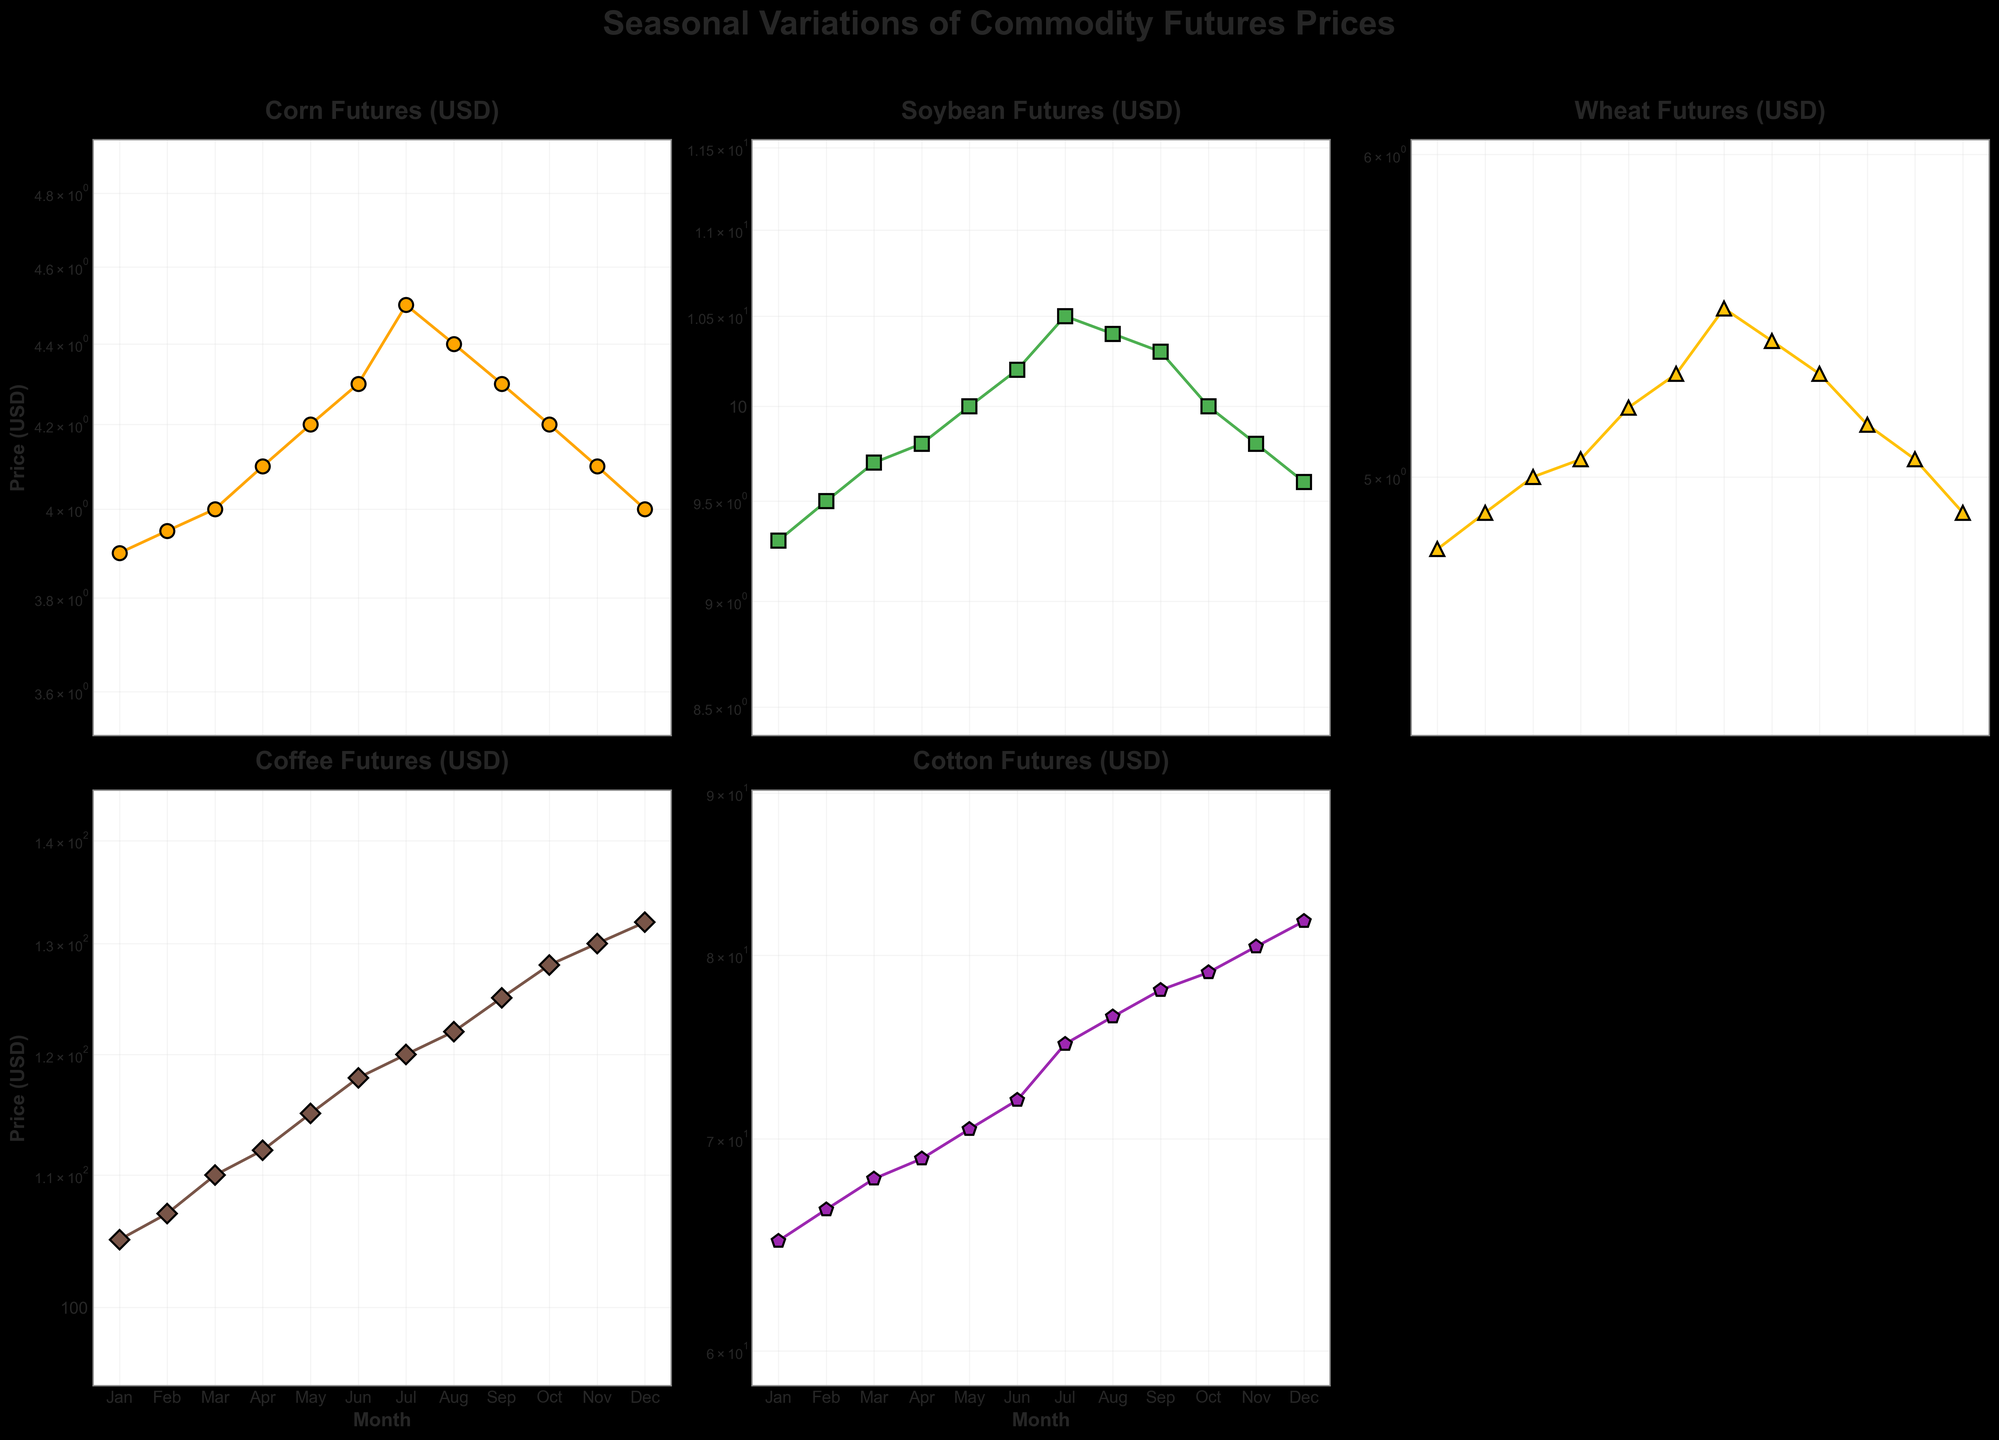Which commodity has the highest futures price in December? By looking at the December prices across all commodities, Coffee Futures is highest with a price of 132.00 USD.
Answer: Coffee How does the futures price of Corn change from March to June? From March to June, the Corn Futures price goes from 4.00 USD to 4.30 USD. By subtracting, we get an increase of 0.30 USD.
Answer: 0.30 USD Which month sees the highest price for Cotton futures? Scanning the Cotton Futures prices reveals the highest price in December at 82.00 USD.
Answer: December What is the price difference between the highest and lowest Soybean futures in the year? The highest price for Soybean Futures is in July at 10.50 USD, and the lowest is in January at 9.30 USD. The price difference is 10.50 - 9.30 = 1.20 USD.
Answer: 1.20 USD In which months does Wheat have a higher futures price than Corn? Comparing Wheat and Corn Futures for each month reveals that Wheat has higher prices in every month of the year.
Answer: Every month Which commodity shows the most significant monthly price decrease and in which month? Examining each commodity's month-to-month change, Corn Futures show a decrease between July and August from 4.50 USD to 4.40 USD, a decrease of 0.10 USD. However, Cotton Futures show a larger decrease from October to November, from 79.00 USD to 80.50 USD, a decrease of 1.50 USD.
Answer: Cotton Futures in November What is the percentage increase in Coffee futures from January to February? Coffee Futures price increases from 105.00 USD in January to 107.00 USD in February. The percentage increase is calculated as ((107 - 105) / 105) * 100 ≈ 1.90%.
Answer: 1.90% Between which two consecutive months does Soybean have the largest price change? Soybean Futures have the largest price change between June (10.20 USD) and July (10.50 USD), where the increase is 0.30 USD.
Answer: June and July Do all commodities follow an upward price trend from January to December? Corn, Soybean, Wheat, Coffee, and Cotton all exhibit different trends. Upon scrutinizing each commodity, all but Corn and Wheat show an end-of-year decrease relative to their highest mid-year points. Thus, not all show a straightforward upward trend.
Answer: No 